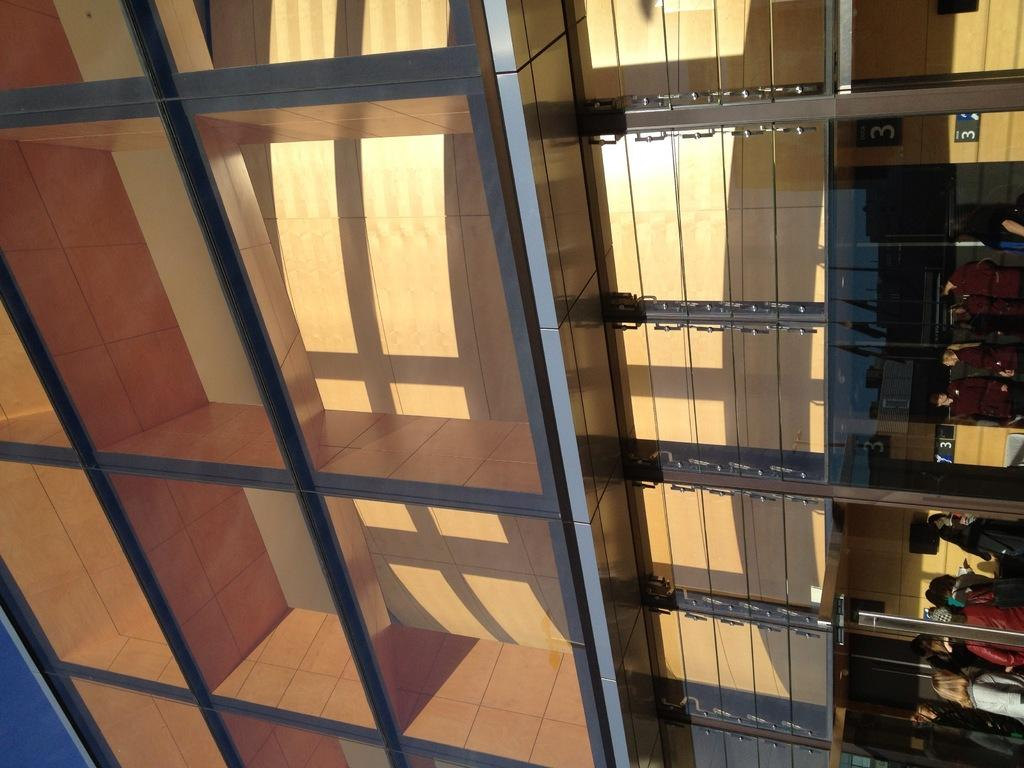<image>
Summarize the visual content of the image. some numbers are fixed on the back board such as number 3 